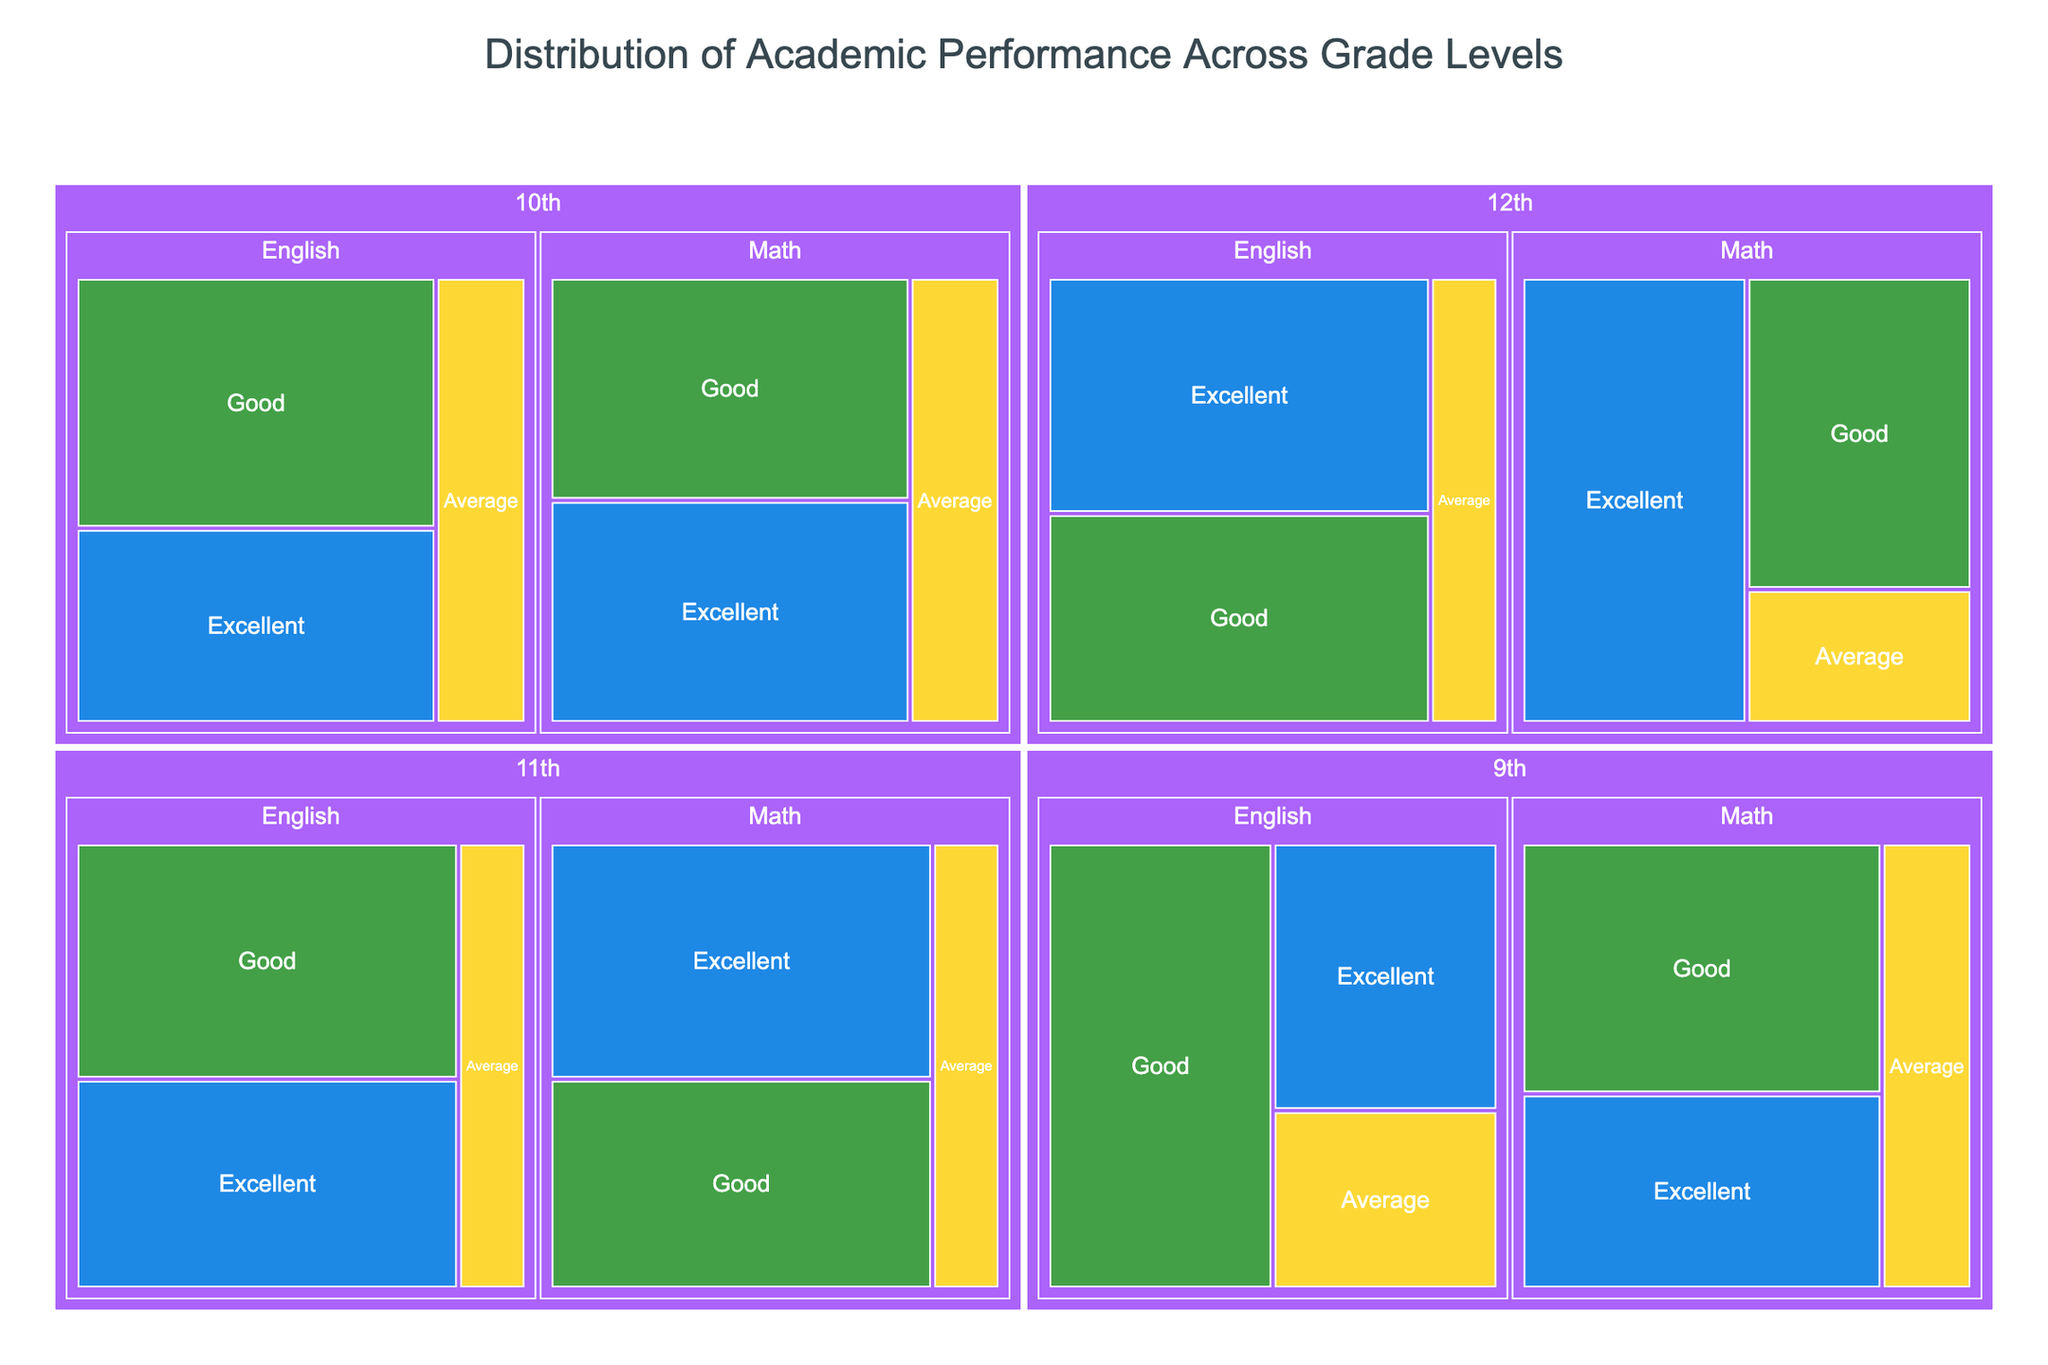What is the title of the treemap? Look at the center top part of the figure to find the title.
Answer: Distribution of Academic Performance Across Grade Levels Which grade level has the highest number of 'Excellent' performances in Math? Compare the 'Excellent' performance segments across all grade levels in the Math category.
Answer: 12th In 9th grade, which subject has the higher total performance? Sum the values of Excellent, Good, and Average for both Math and English in 9th grade.
Answer: English What is the total number of students in 10th grade? Add up all values for 10th grade across both subjects and performance categories.
Answer: 240 Which performance category has the most uniform distribution across all grade levels for English? Compare the segments of Excellent, Good, and Average for English at all grade levels.
Answer: Average How many students have an 'Average' performance in Math across all grade levels? Sum the 'Average' values for Math across 9th, 10th, 11th, and 12th grades.
Answer: 70 Which grade level has the smallest segment for 'Average' performance in English? Look for the smallest 'Average' performance category segment in English across all grade levels.
Answer: 11th and 12th What is the proportion of 'Good' performance in Math for 11th grade compared to the total Math performance in 11th grade? Find the fraction of 'Good' performance to the total Math performance for 11th grade and convert it to a percentage.
Answer: 40/(45+40+15) = 40% Which has more 'Excellent' performers, 11th grade Math or 10th grade English? Compare the 'Excellent' performance values between 11th grade Math and 10th grade English.
Answer: 11th grade Math What is the overall trend of 'Excellent' performance from 9th grade to 12th grade in Math? Observe the size of 'Excellent' segments in Math across the grade levels.
Answer: Increasing trend 